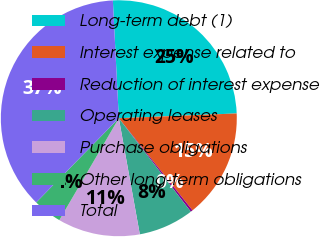<chart> <loc_0><loc_0><loc_500><loc_500><pie_chart><fcel>Long-term debt (1)<fcel>Interest expense related to<fcel>Reduction of interest expense<fcel>Operating leases<fcel>Purchase obligations<fcel>Other long-term obligations<fcel>Total<nl><fcel>25.16%<fcel>14.91%<fcel>0.29%<fcel>7.6%<fcel>11.26%<fcel>3.94%<fcel>36.85%<nl></chart> 